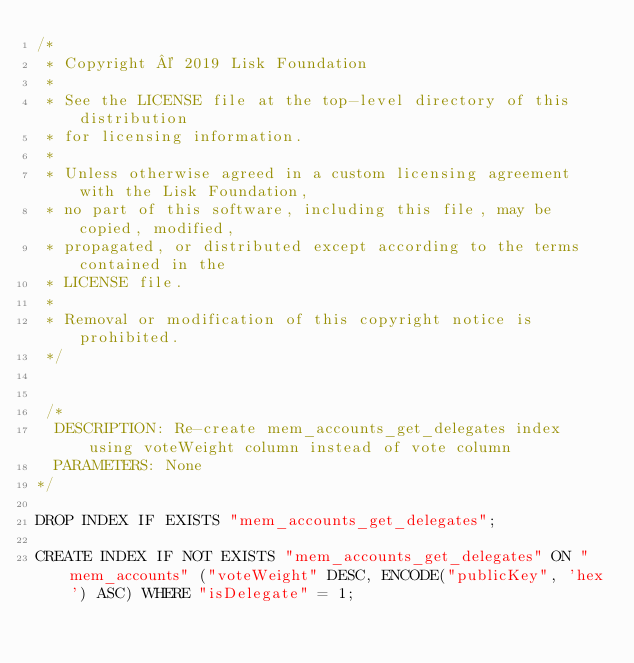Convert code to text. <code><loc_0><loc_0><loc_500><loc_500><_SQL_>/*
 * Copyright © 2019 Lisk Foundation
 *
 * See the LICENSE file at the top-level directory of this distribution
 * for licensing information.
 *
 * Unless otherwise agreed in a custom licensing agreement with the Lisk Foundation,
 * no part of this software, including this file, may be copied, modified,
 * propagated, or distributed except according to the terms contained in the
 * LICENSE file.
 *
 * Removal or modification of this copyright notice is prohibited.
 */


 /*
  DESCRIPTION: Re-create mem_accounts_get_delegates index using voteWeight column instead of vote column
  PARAMETERS: None
*/

DROP INDEX IF EXISTS "mem_accounts_get_delegates";

CREATE INDEX IF NOT EXISTS "mem_accounts_get_delegates" ON "mem_accounts" ("voteWeight" DESC, ENCODE("publicKey", 'hex') ASC) WHERE "isDelegate" = 1;
</code> 